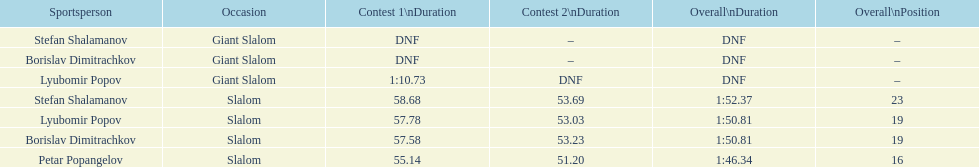How long did it take for lyubomir popov to finish the giant slalom in race 1? 1:10.73. 